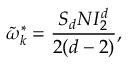Convert formula to latex. <formula><loc_0><loc_0><loc_500><loc_500>\tilde { \omega } _ { k } ^ { * } = \frac { S _ { d } N I _ { 2 } ^ { d } } { 2 ( d - 2 ) } ,</formula> 